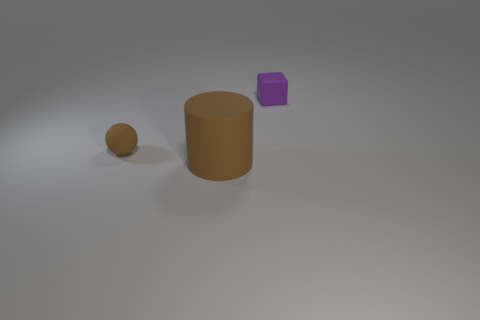Is there any other thing that has the same size as the cylinder?
Ensure brevity in your answer.  No. There is a thing that is to the left of the small rubber block and behind the large thing; what color is it?
Offer a terse response. Brown. Are there any tiny brown objects made of the same material as the small block?
Provide a succinct answer. Yes. The rubber cylinder has what size?
Your answer should be very brief. Large. What size is the brown rubber object right of the tiny matte thing in front of the small matte block?
Your response must be concise. Large. What number of small matte blocks are there?
Offer a very short reply. 1. There is a tiny matte object left of the matte object that is behind the tiny object that is on the left side of the purple block; what is its color?
Provide a succinct answer. Brown. Is the number of large brown objects less than the number of green matte cylinders?
Ensure brevity in your answer.  No. What is the color of the block that is made of the same material as the large brown cylinder?
Offer a very short reply. Purple. What number of brown rubber balls have the same size as the block?
Your answer should be compact. 1. 